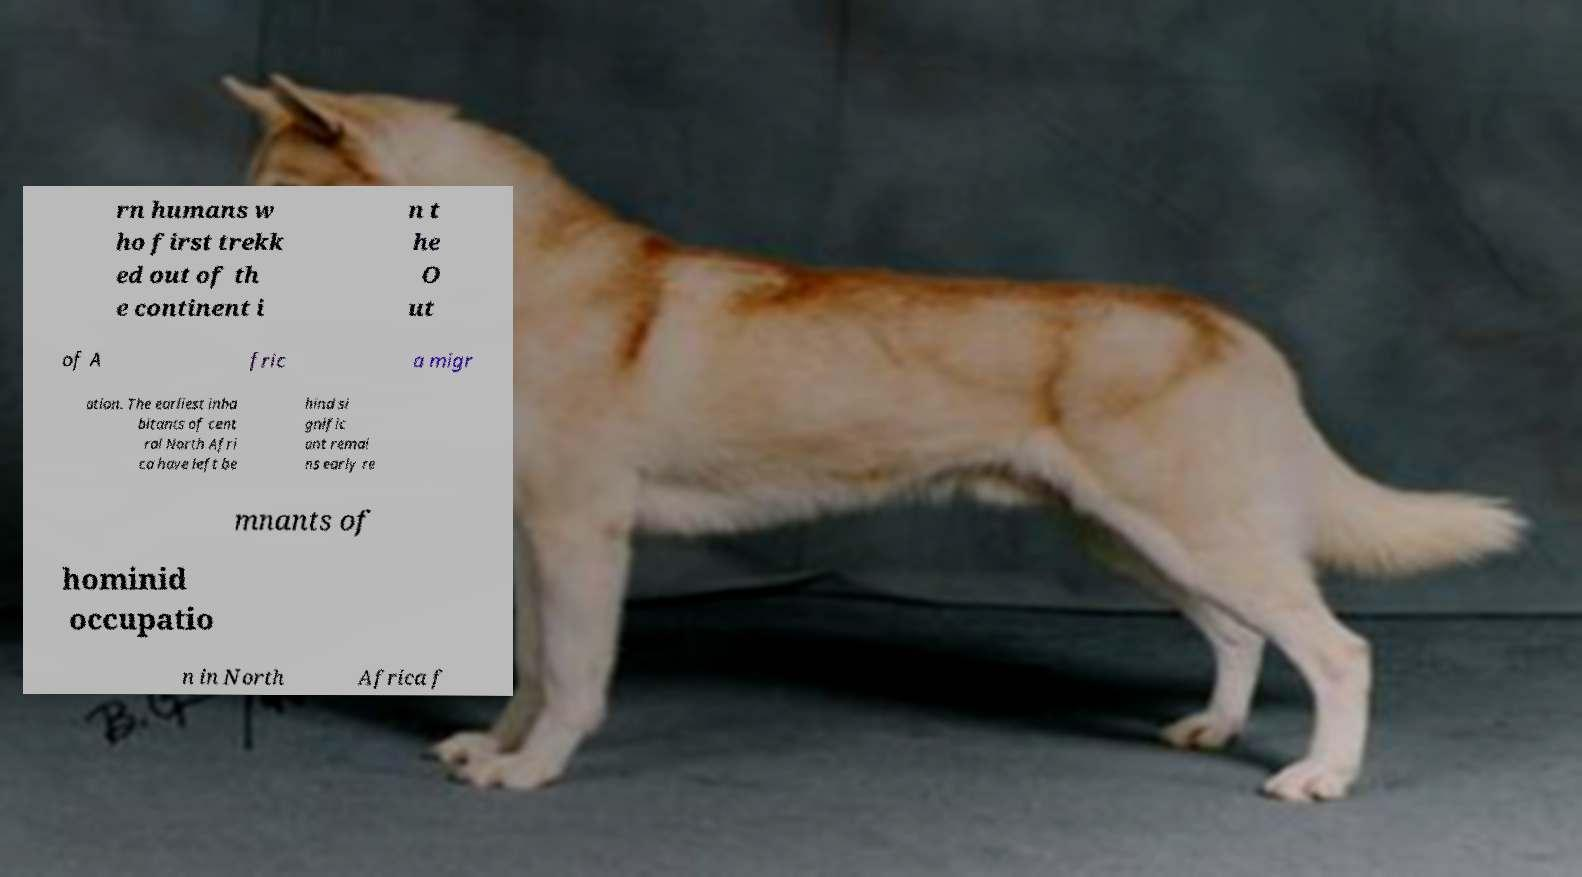Please read and relay the text visible in this image. What does it say? rn humans w ho first trekk ed out of th e continent i n t he O ut of A fric a migr ation. The earliest inha bitants of cent ral North Afri ca have left be hind si gnific ant remai ns early re mnants of hominid occupatio n in North Africa f 